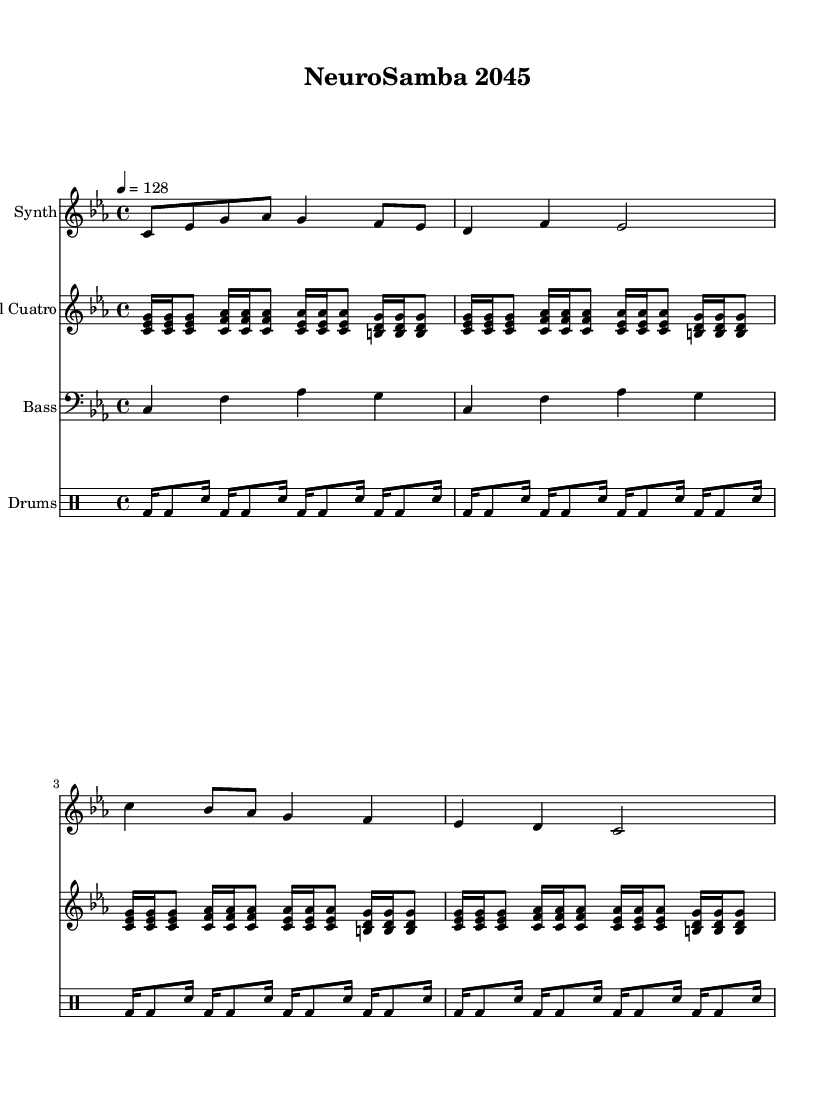What is the key signature of this music? The key signature is indicated at the beginning of the staff. In this piece, it is C minor, which has three flats (B flat, E flat, and A flat).
Answer: C minor What is the time signature of this music? The time signature is found at the beginning of the music notation, where it reads 4/4. This means there are four beats in a measure and the quarter note gets one beat.
Answer: 4/4 What is the tempo marking for this piece? The tempo marking is shown in beats per minute (BPM). In this case, it is indicated as 4 = 128, meaning the piece should be played at a speed of 128 beats per minute.
Answer: 128 How many measures are present in the synth melody? By counting the individual measures in the synthesized melody staff, we can see that the melody consists of 4 measures.
Answer: 4 What type of drum pattern is used in this music? In the music notation for the drums, we can observe a pattern using bass drums (bd) and snare drums (sn). This indicates a standard Latin rhythm which emphasizes the groove.
Answer: Latin rhythm What is the instrumental family of the "Digital Cuatro"? The "Digital Cuatro" is notated within the staff specifically dedicated to it. The name suggests it is a string instrument likely resembling the traditional Cuatro, which belongs to the string family.
Answer: String What is unique about the melody with respect to the style of Latin music? Analyzing the overall structure, we note that the melody combines electronic sounds typical in fusion genres while incorporating rhythmic elements common in Latin music styles, creating an innovative blend.
Answer: Fusion 